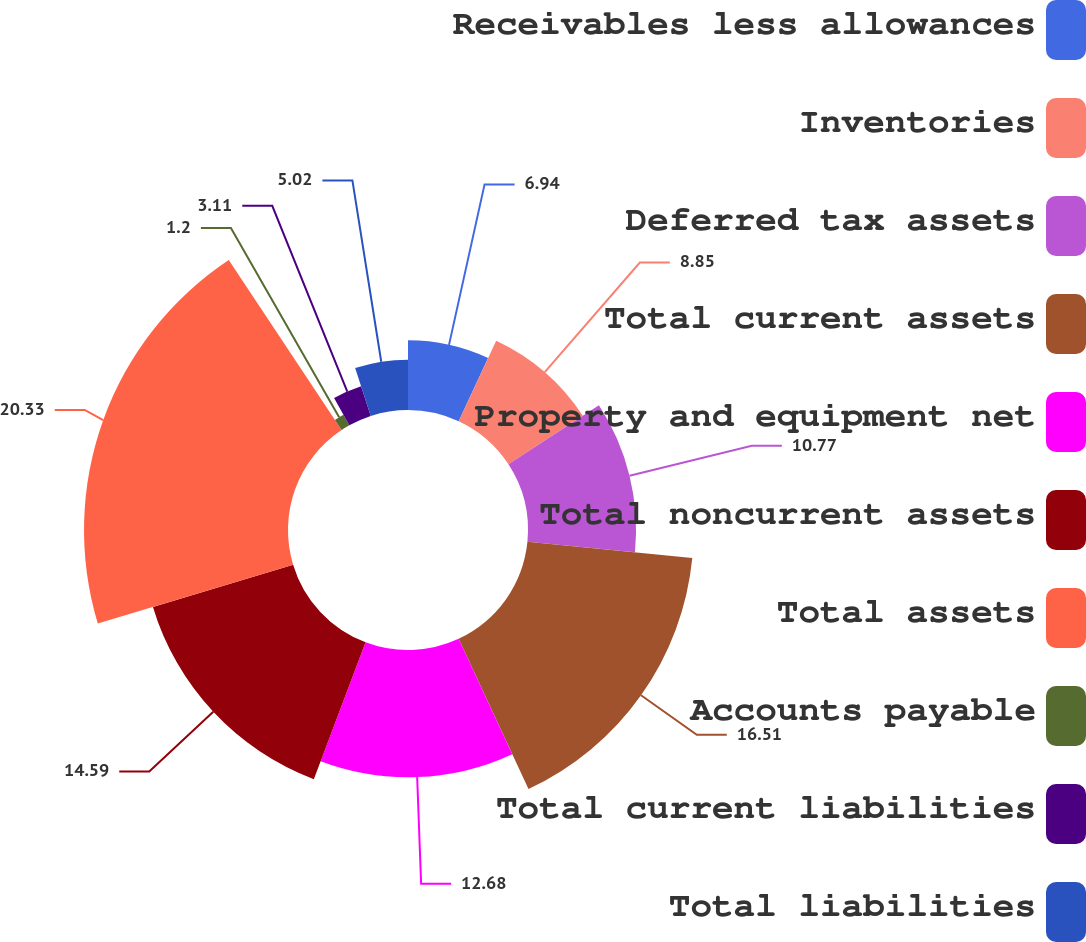Convert chart. <chart><loc_0><loc_0><loc_500><loc_500><pie_chart><fcel>Receivables less allowances<fcel>Inventories<fcel>Deferred tax assets<fcel>Total current assets<fcel>Property and equipment net<fcel>Total noncurrent assets<fcel>Total assets<fcel>Accounts payable<fcel>Total current liabilities<fcel>Total liabilities<nl><fcel>6.94%<fcel>8.85%<fcel>10.77%<fcel>16.51%<fcel>12.68%<fcel>14.59%<fcel>20.33%<fcel>1.2%<fcel>3.11%<fcel>5.02%<nl></chart> 